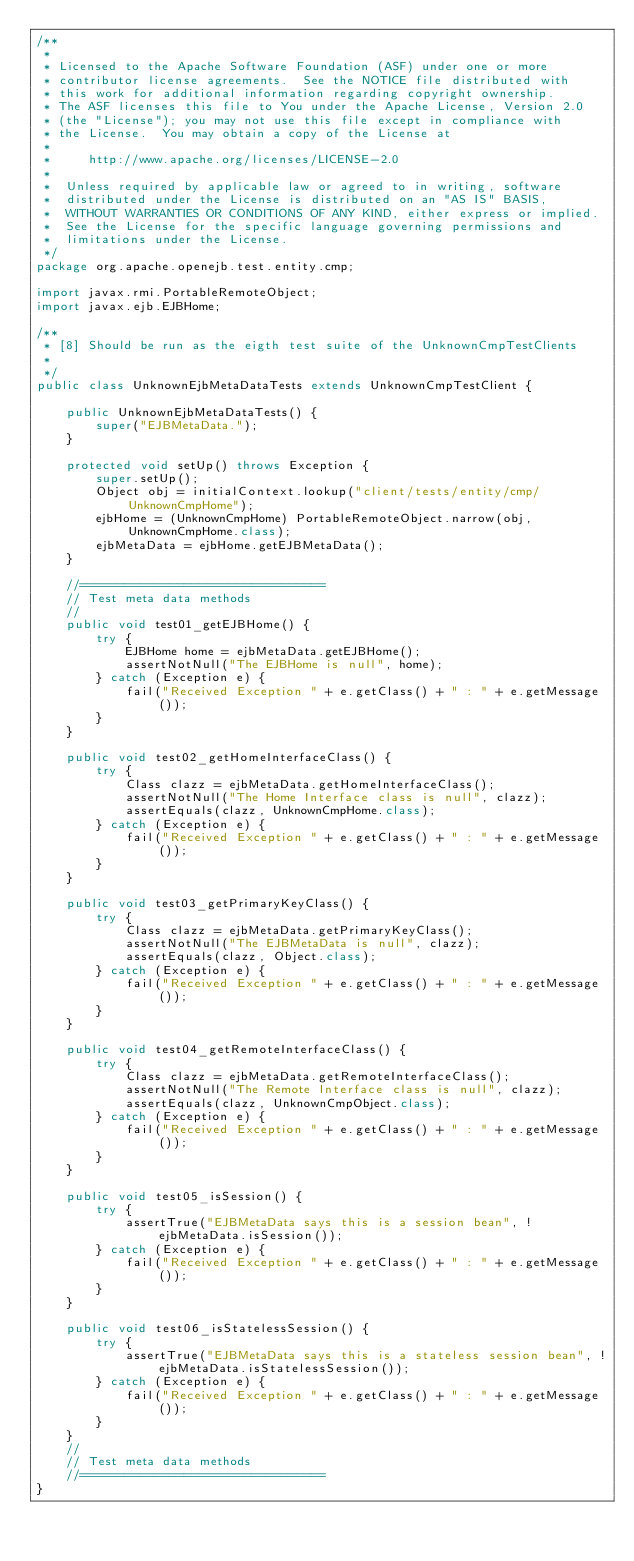<code> <loc_0><loc_0><loc_500><loc_500><_Java_>/**
 *
 * Licensed to the Apache Software Foundation (ASF) under one or more
 * contributor license agreements.  See the NOTICE file distributed with
 * this work for additional information regarding copyright ownership.
 * The ASF licenses this file to You under the Apache License, Version 2.0
 * (the "License"); you may not use this file except in compliance with
 * the License.  You may obtain a copy of the License at
 *
 *     http://www.apache.org/licenses/LICENSE-2.0
 *
 *  Unless required by applicable law or agreed to in writing, software
 *  distributed under the License is distributed on an "AS IS" BASIS,
 *  WITHOUT WARRANTIES OR CONDITIONS OF ANY KIND, either express or implied.
 *  See the License for the specific language governing permissions and
 *  limitations under the License.
 */
package org.apache.openejb.test.entity.cmp;

import javax.rmi.PortableRemoteObject;
import javax.ejb.EJBHome;

/**
 * [8] Should be run as the eigth test suite of the UnknownCmpTestClients
 *
 */
public class UnknownEjbMetaDataTests extends UnknownCmpTestClient {

    public UnknownEjbMetaDataTests() {
        super("EJBMetaData.");
    }

    protected void setUp() throws Exception {
        super.setUp();
        Object obj = initialContext.lookup("client/tests/entity/cmp/UnknownCmpHome");
        ejbHome = (UnknownCmpHome) PortableRemoteObject.narrow(obj, UnknownCmpHome.class);
        ejbMetaData = ejbHome.getEJBMetaData();
    }

    //=================================
    // Test meta data methods
    //
    public void test01_getEJBHome() {
        try {
            EJBHome home = ejbMetaData.getEJBHome();
            assertNotNull("The EJBHome is null", home);
        } catch (Exception e) {
            fail("Received Exception " + e.getClass() + " : " + e.getMessage());
        }
    }

    public void test02_getHomeInterfaceClass() {
        try {
            Class clazz = ejbMetaData.getHomeInterfaceClass();
            assertNotNull("The Home Interface class is null", clazz);
            assertEquals(clazz, UnknownCmpHome.class);
        } catch (Exception e) {
            fail("Received Exception " + e.getClass() + " : " + e.getMessage());
        }
    }

    public void test03_getPrimaryKeyClass() {
        try {
            Class clazz = ejbMetaData.getPrimaryKeyClass();
            assertNotNull("The EJBMetaData is null", clazz);
            assertEquals(clazz, Object.class);
        } catch (Exception e) {
            fail("Received Exception " + e.getClass() + " : " + e.getMessage());
        }
    }

    public void test04_getRemoteInterfaceClass() {
        try {
            Class clazz = ejbMetaData.getRemoteInterfaceClass();
            assertNotNull("The Remote Interface class is null", clazz);
            assertEquals(clazz, UnknownCmpObject.class);
        } catch (Exception e) {
            fail("Received Exception " + e.getClass() + " : " + e.getMessage());
        }
    }

    public void test05_isSession() {
        try {
            assertTrue("EJBMetaData says this is a session bean", !ejbMetaData.isSession());
        } catch (Exception e) {
            fail("Received Exception " + e.getClass() + " : " + e.getMessage());
        }
    }

    public void test06_isStatelessSession() {
        try {
            assertTrue("EJBMetaData says this is a stateless session bean", !ejbMetaData.isStatelessSession());
        } catch (Exception e) {
            fail("Received Exception " + e.getClass() + " : " + e.getMessage());
        }
    }
    //
    // Test meta data methods
    //=================================
}
</code> 